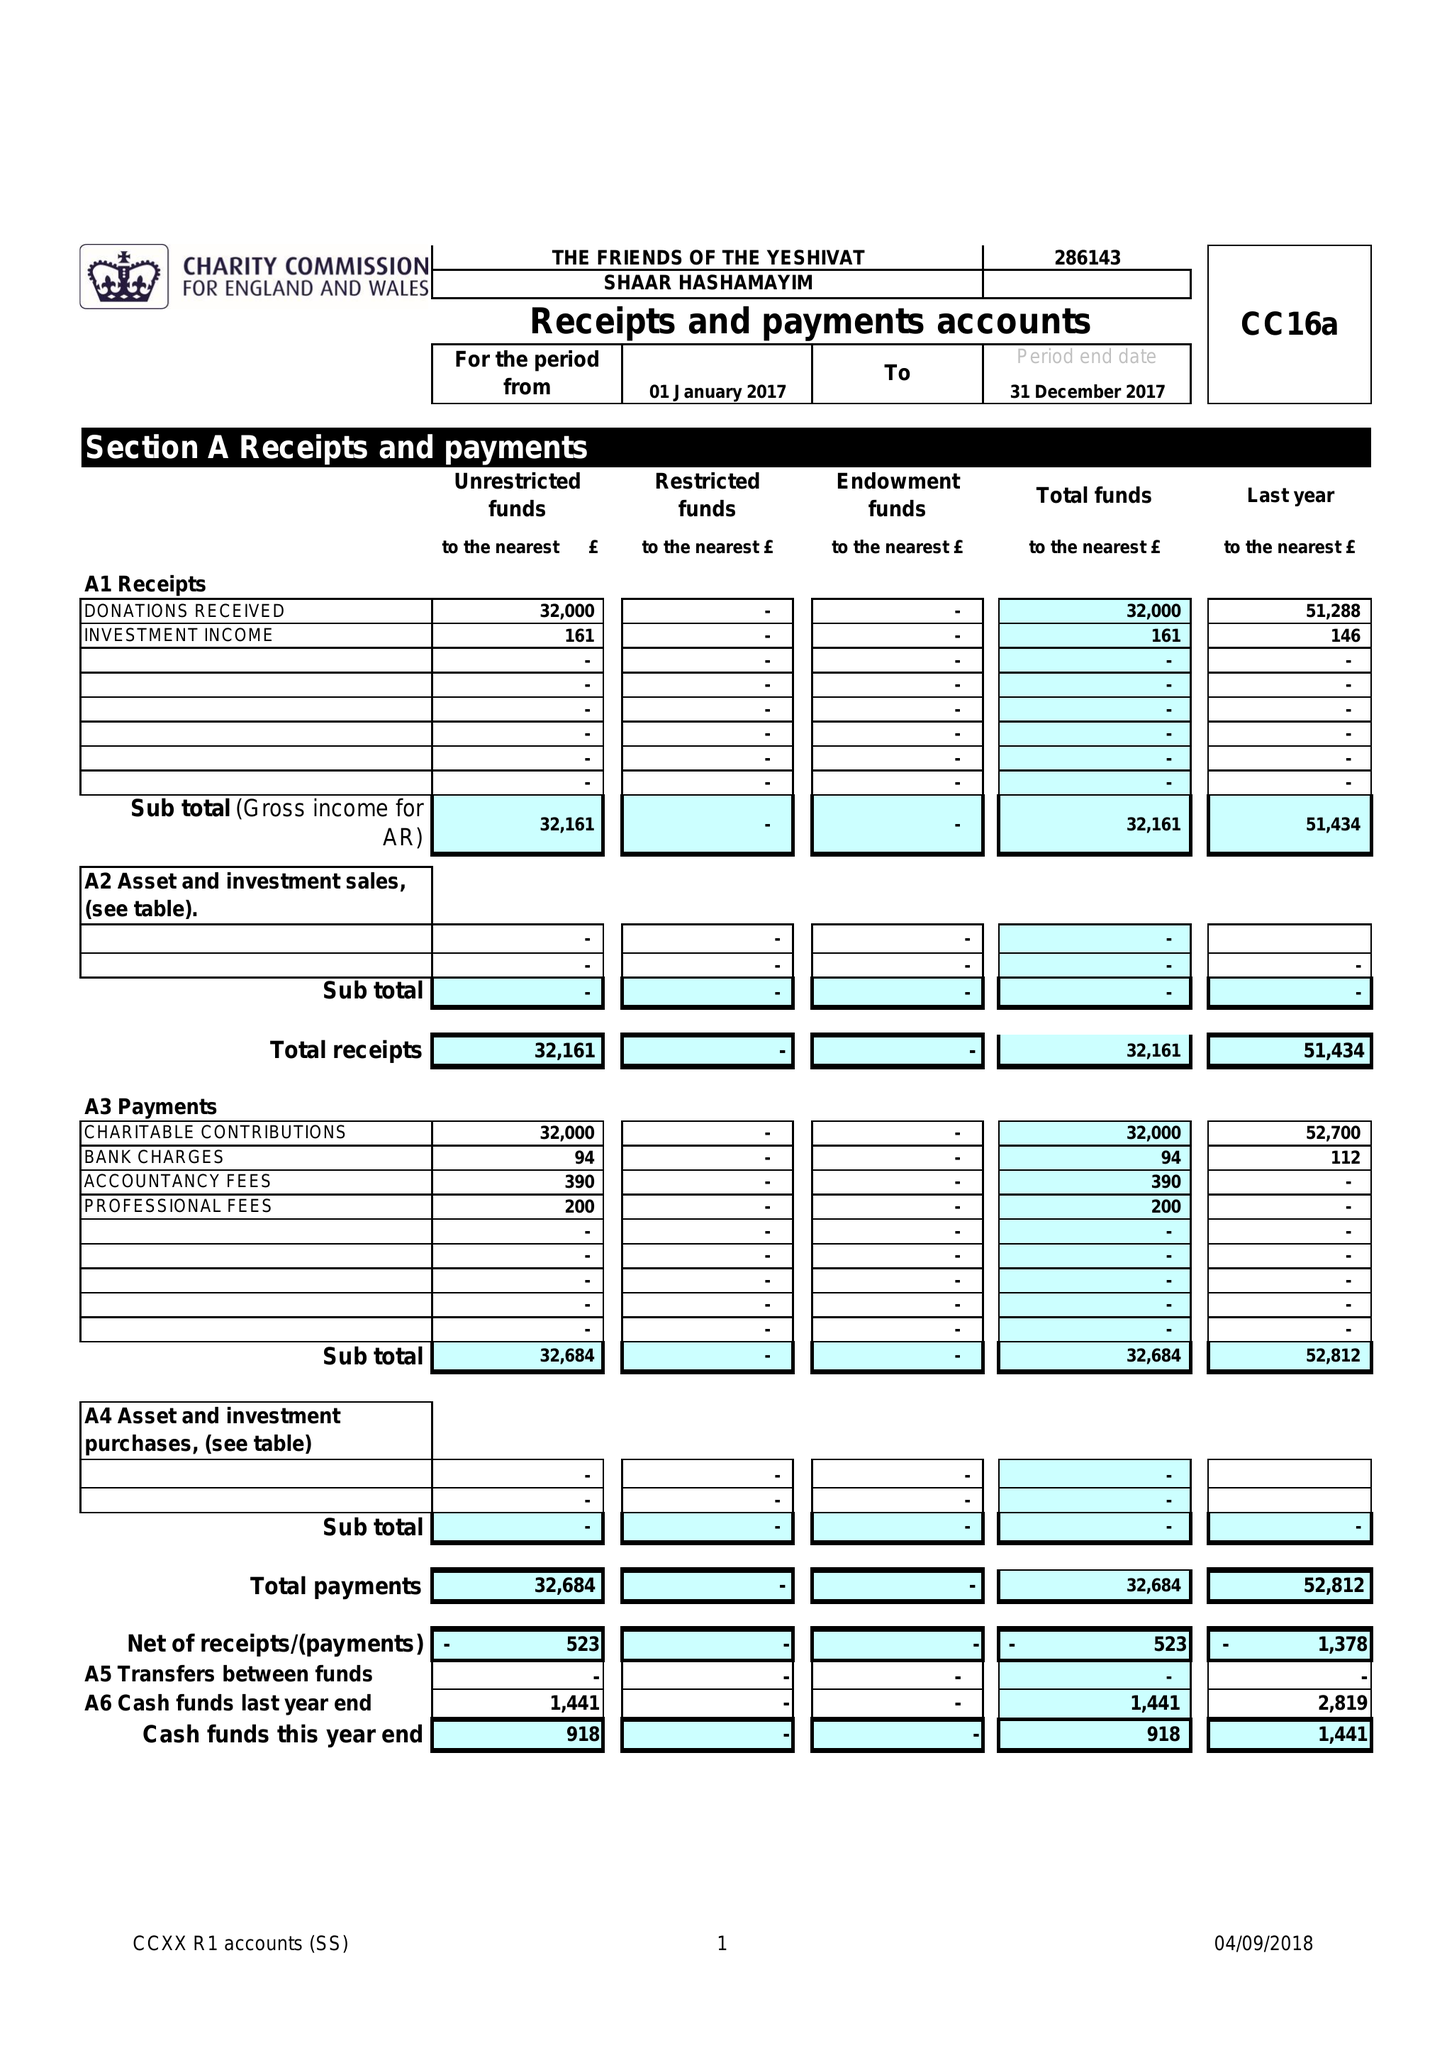What is the value for the address__postcode?
Answer the question using a single word or phrase. NW11 8AA 